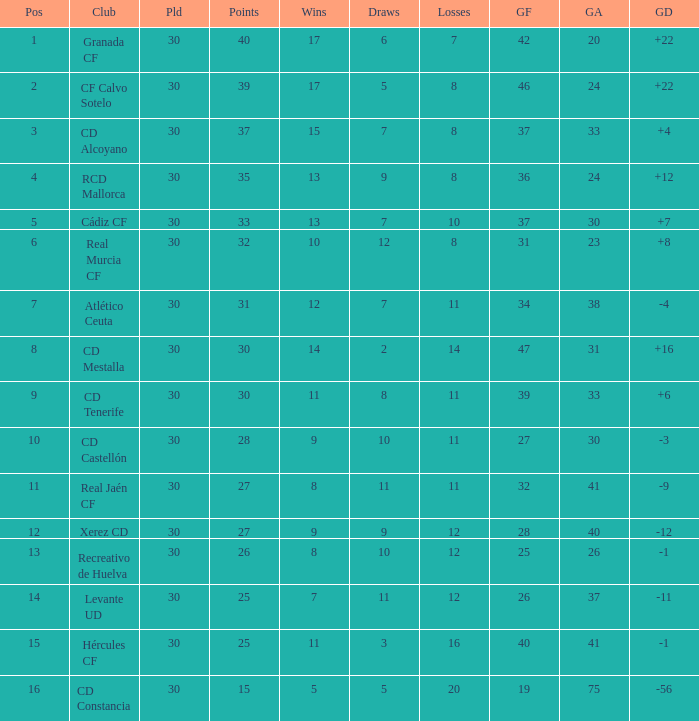Which Wins have a Goal Difference larger than 12, and a Club of granada cf, and Played larger than 30? None. 